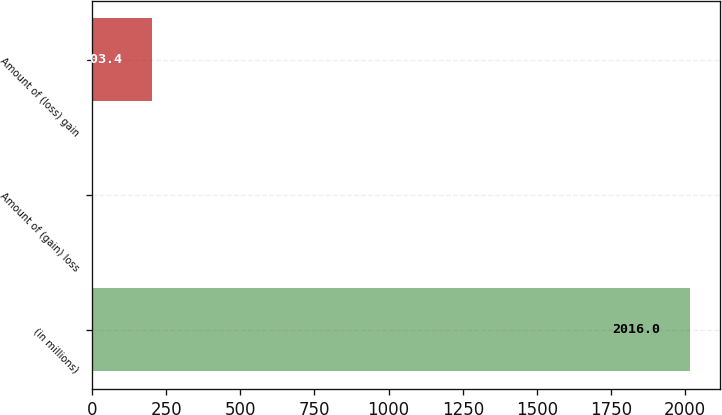Convert chart. <chart><loc_0><loc_0><loc_500><loc_500><bar_chart><fcel>(in millions)<fcel>Amount of (gain) loss<fcel>Amount of (loss) gain<nl><fcel>2016<fcel>2<fcel>203.4<nl></chart> 